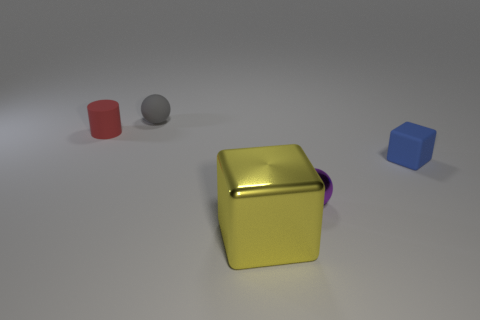Subtract 1 cubes. How many cubes are left? 1 Add 2 purple shiny cylinders. How many objects exist? 7 Subtract all blue blocks. How many blocks are left? 1 Subtract all green spheres. Subtract all red cylinders. How many spheres are left? 2 Subtract all blue balls. How many red blocks are left? 0 Subtract all tiny blue things. Subtract all large things. How many objects are left? 3 Add 2 big yellow shiny things. How many big yellow shiny things are left? 3 Add 2 small shiny objects. How many small shiny objects exist? 3 Subtract 0 yellow balls. How many objects are left? 5 Subtract all cubes. How many objects are left? 3 